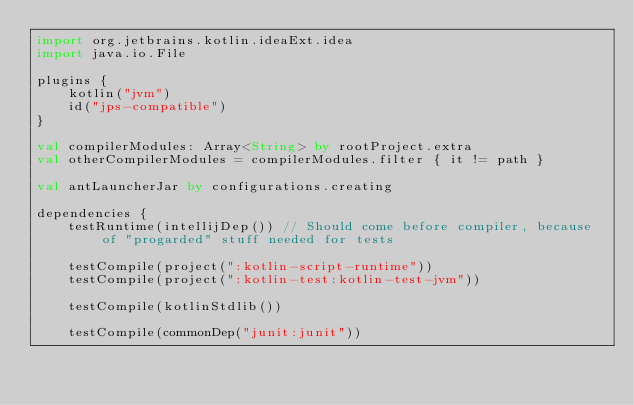<code> <loc_0><loc_0><loc_500><loc_500><_Kotlin_>import org.jetbrains.kotlin.ideaExt.idea
import java.io.File

plugins {
    kotlin("jvm")
    id("jps-compatible")
}

val compilerModules: Array<String> by rootProject.extra
val otherCompilerModules = compilerModules.filter { it != path }

val antLauncherJar by configurations.creating

dependencies {
    testRuntime(intellijDep()) // Should come before compiler, because of "progarded" stuff needed for tests

    testCompile(project(":kotlin-script-runtime"))
    testCompile(project(":kotlin-test:kotlin-test-jvm"))
    
    testCompile(kotlinStdlib())

    testCompile(commonDep("junit:junit"))</code> 